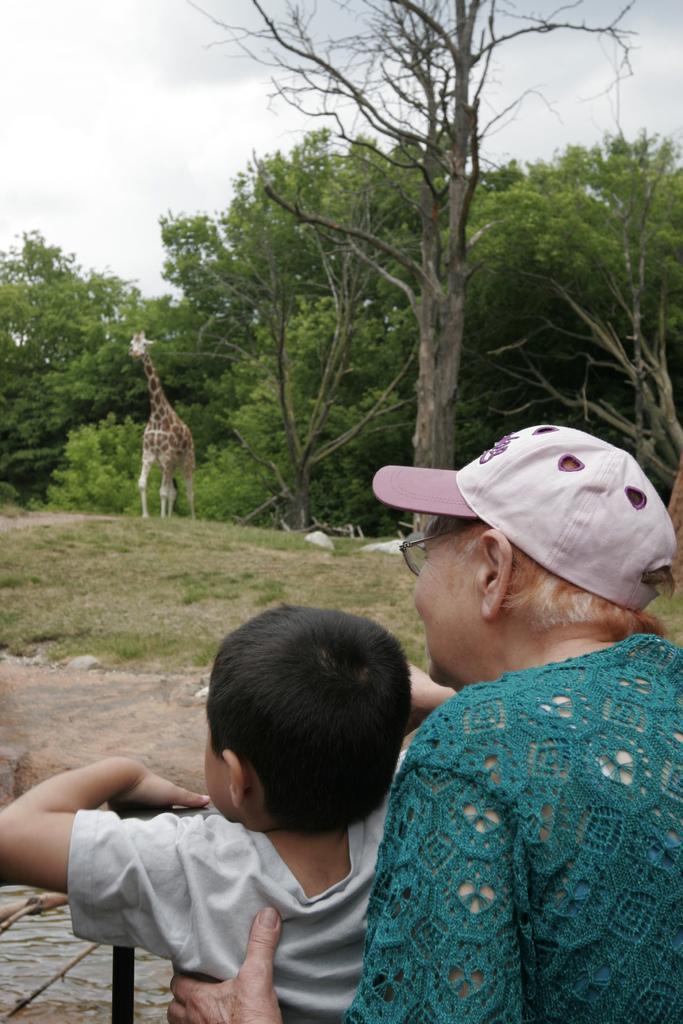How would you summarize this image in a sentence or two? In this image I can see two persons. I can see a giraffe. There are few trees. I can see clouds in the sky. 